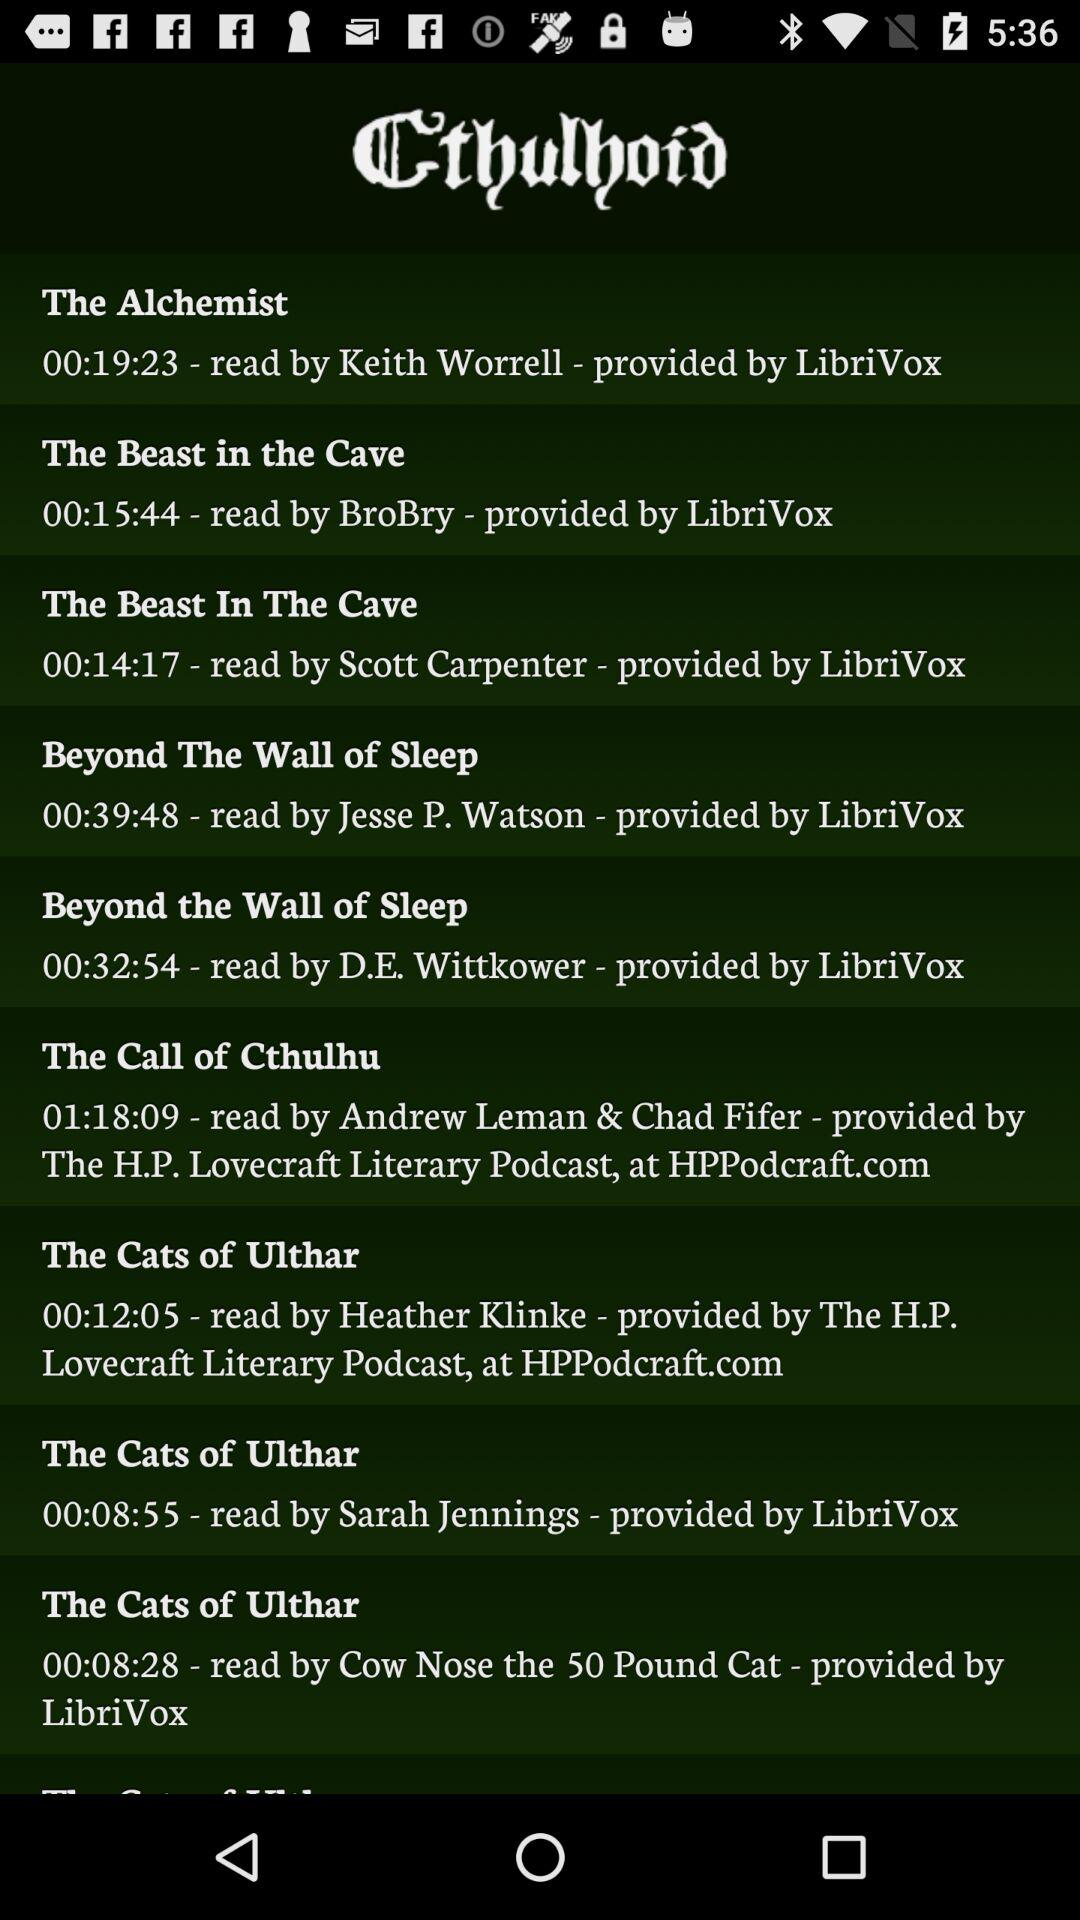Who provided "Beyond The Wall of Sleep"? It is provided by "LibriVox". 